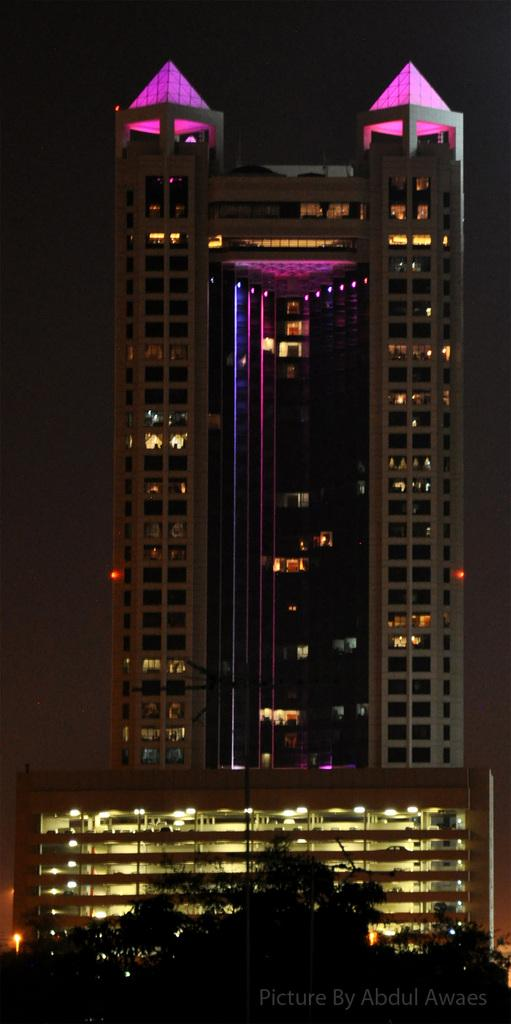What type of vegetation is in the foreground of the image? There are trees in the foreground of the image. What structure is located in the center of the image? There is a building in the center of the image. Can you describe the type of building in the center of the image? There is a skyscraper in the center of the image. What holiday is being advertised in the image? There is no advertisement or holiday mentioned or depicted in the image. 